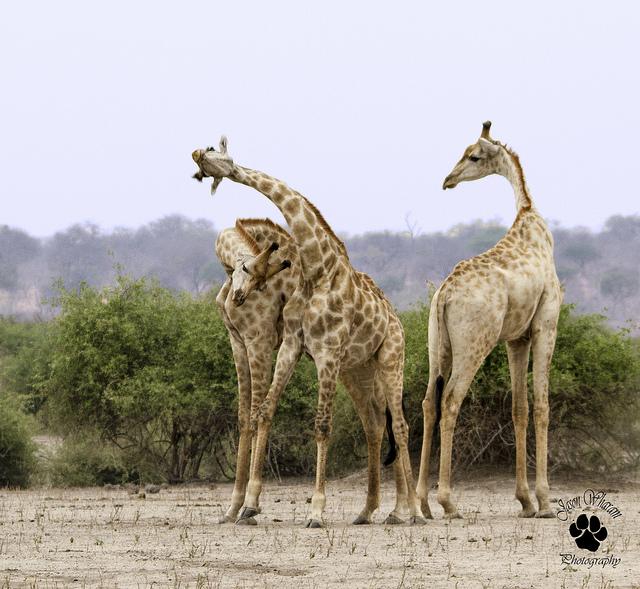What kind of animals are shown?
Give a very brief answer. Giraffes. Is this a gravel road?
Be succinct. No. Are the animals eating?
Answer briefly. No. Why do these animals have fur?
Quick response, please. Warmth. How many animals in the picture?
Write a very short answer. 3. How many giraffes are in the wild?
Be succinct. 3. Are all the animals facing the same direction?
Keep it brief. No. 